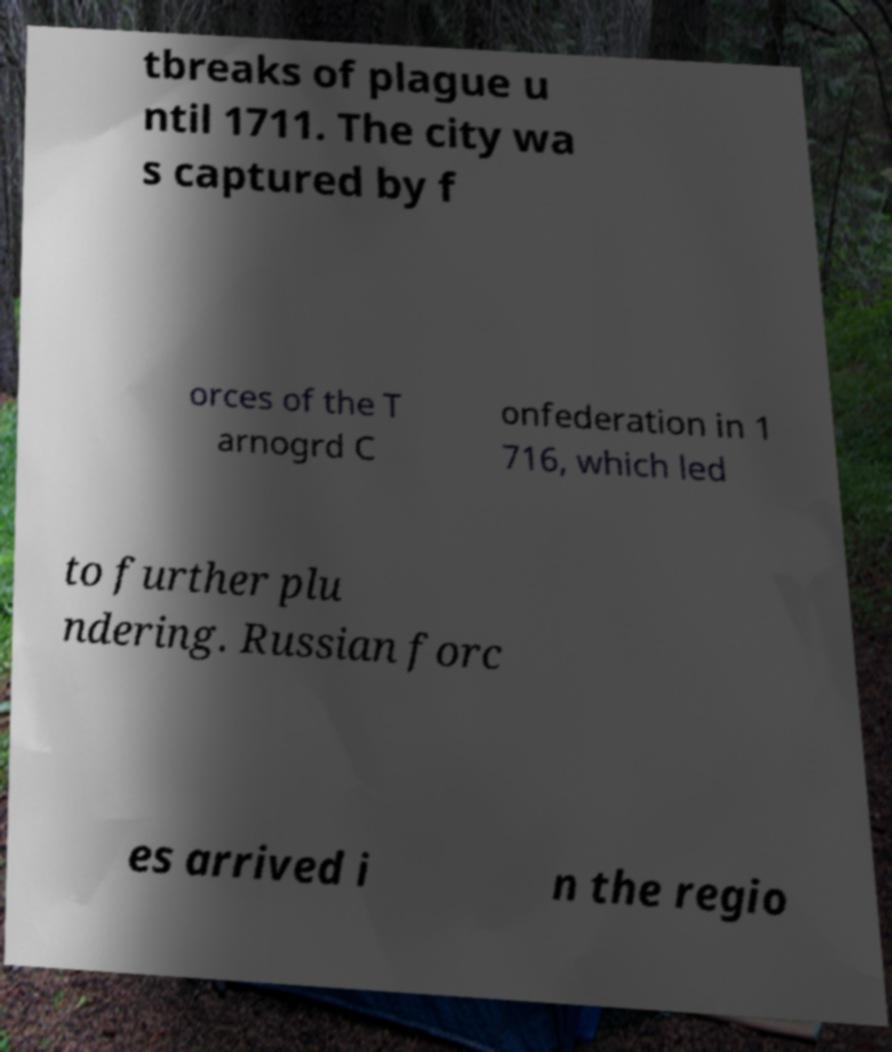There's text embedded in this image that I need extracted. Can you transcribe it verbatim? tbreaks of plague u ntil 1711. The city wa s captured by f orces of the T arnogrd C onfederation in 1 716, which led to further plu ndering. Russian forc es arrived i n the regio 